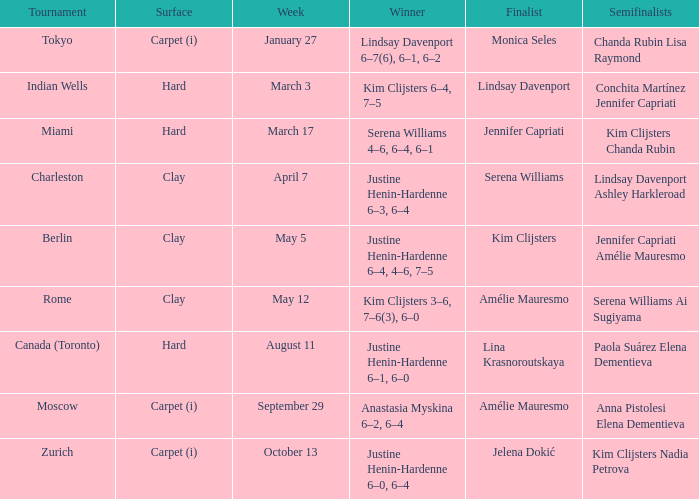Who triumphed over lindsay davenport? Kim Clijsters 6–4, 7–5. 